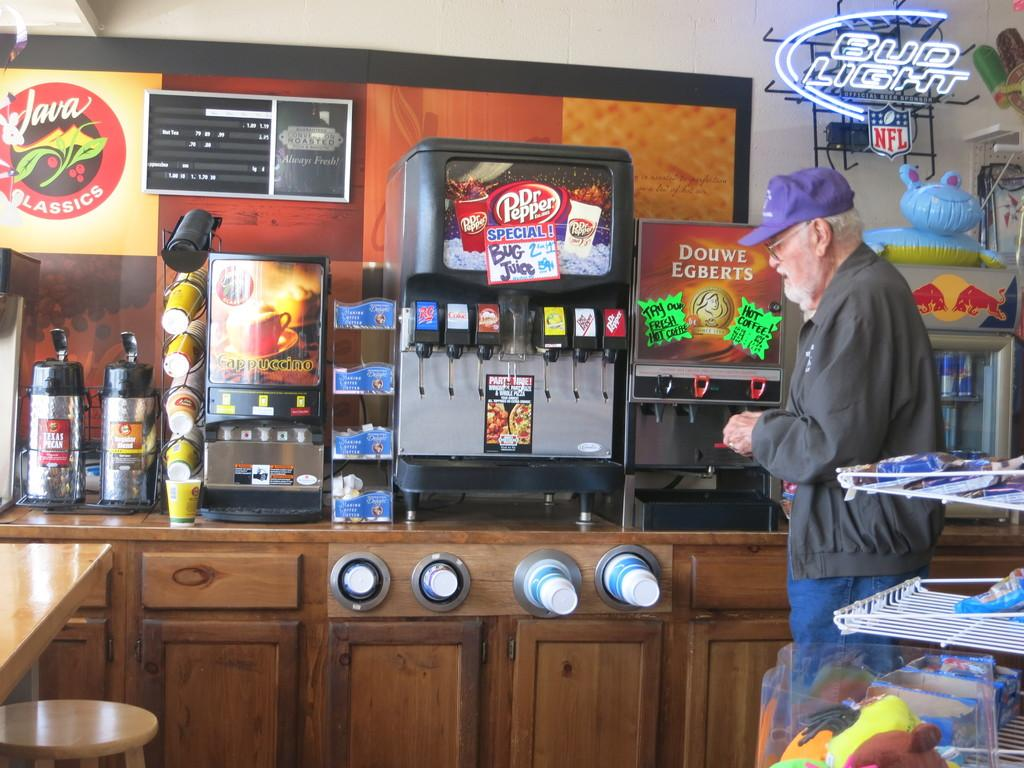Who is present in the image? There is a man in the image. What is the man standing in front of? The man is standing in front of machines. Where are the machines located? The machines are located on a table. What can be seen in the background of the image? There are toys and a fridge in the background of the image. What type of toothpaste is the man using in the image? There is no toothpaste present in the image. How does the man measure the machines in the image? The man is not measuring the machines in the image; he is simply standing in front of them. 